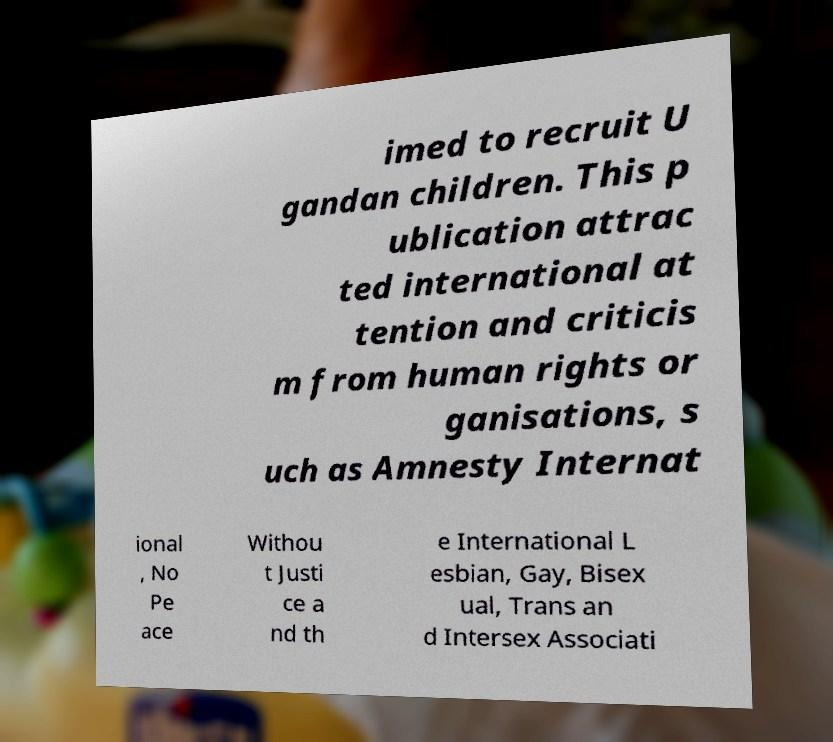There's text embedded in this image that I need extracted. Can you transcribe it verbatim? imed to recruit U gandan children. This p ublication attrac ted international at tention and criticis m from human rights or ganisations, s uch as Amnesty Internat ional , No Pe ace Withou t Justi ce a nd th e International L esbian, Gay, Bisex ual, Trans an d Intersex Associati 